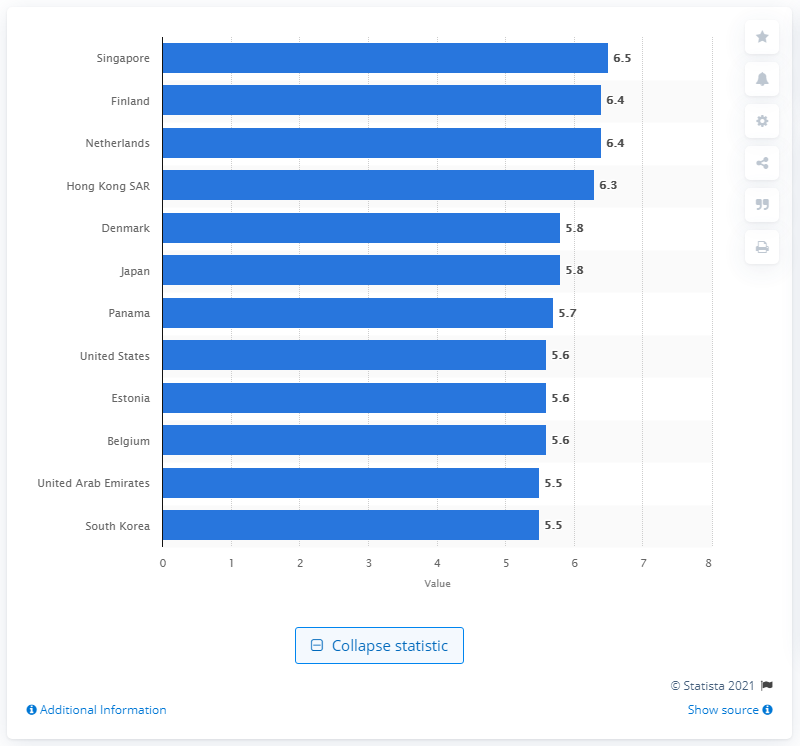Draw attention to some important aspects in this diagram. Singapore had the highest seaport quality in 2018, according to the latest data. The United States received a rating of 5.6 on a scale from 1 (under-developed) to 7 (extensively developed according to international standards) in a assessment of its development level. 